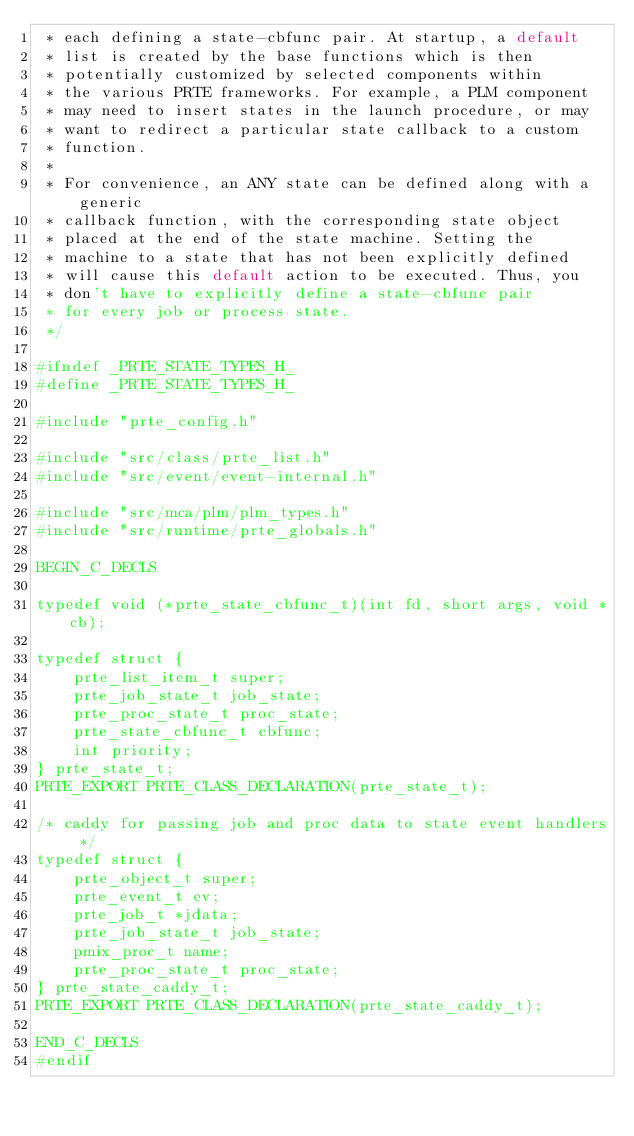Convert code to text. <code><loc_0><loc_0><loc_500><loc_500><_C_> * each defining a state-cbfunc pair. At startup, a default
 * list is created by the base functions which is then
 * potentially customized by selected components within
 * the various PRTE frameworks. For example, a PLM component
 * may need to insert states in the launch procedure, or may
 * want to redirect a particular state callback to a custom
 * function.
 *
 * For convenience, an ANY state can be defined along with a generic
 * callback function, with the corresponding state object
 * placed at the end of the state machine. Setting the
 * machine to a state that has not been explicitly defined
 * will cause this default action to be executed. Thus, you
 * don't have to explicitly define a state-cbfunc pair
 * for every job or process state.
 */

#ifndef _PRTE_STATE_TYPES_H_
#define _PRTE_STATE_TYPES_H_

#include "prte_config.h"

#include "src/class/prte_list.h"
#include "src/event/event-internal.h"

#include "src/mca/plm/plm_types.h"
#include "src/runtime/prte_globals.h"

BEGIN_C_DECLS

typedef void (*prte_state_cbfunc_t)(int fd, short args, void *cb);

typedef struct {
    prte_list_item_t super;
    prte_job_state_t job_state;
    prte_proc_state_t proc_state;
    prte_state_cbfunc_t cbfunc;
    int priority;
} prte_state_t;
PRTE_EXPORT PRTE_CLASS_DECLARATION(prte_state_t);

/* caddy for passing job and proc data to state event handlers */
typedef struct {
    prte_object_t super;
    prte_event_t ev;
    prte_job_t *jdata;
    prte_job_state_t job_state;
    pmix_proc_t name;
    prte_proc_state_t proc_state;
} prte_state_caddy_t;
PRTE_EXPORT PRTE_CLASS_DECLARATION(prte_state_caddy_t);

END_C_DECLS
#endif
</code> 